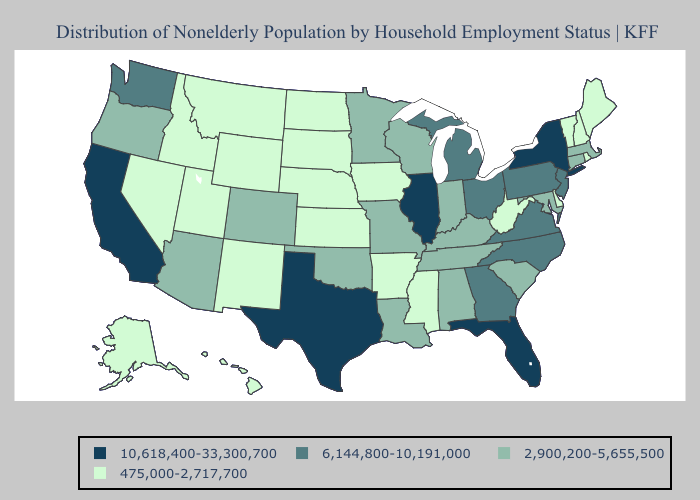Which states hav the highest value in the South?
Short answer required. Florida, Texas. Does South Carolina have the lowest value in the USA?
Write a very short answer. No. What is the highest value in the USA?
Answer briefly. 10,618,400-33,300,700. Does Alaska have the highest value in the USA?
Write a very short answer. No. What is the value of Massachusetts?
Be succinct. 2,900,200-5,655,500. Does Iowa have the lowest value in the MidWest?
Be succinct. Yes. Does the first symbol in the legend represent the smallest category?
Keep it brief. No. What is the value of Washington?
Be succinct. 6,144,800-10,191,000. Which states have the highest value in the USA?
Write a very short answer. California, Florida, Illinois, New York, Texas. Does Kansas have the lowest value in the USA?
Give a very brief answer. Yes. Name the states that have a value in the range 6,144,800-10,191,000?
Concise answer only. Georgia, Michigan, New Jersey, North Carolina, Ohio, Pennsylvania, Virginia, Washington. What is the highest value in the MidWest ?
Be succinct. 10,618,400-33,300,700. Does the map have missing data?
Be succinct. No. How many symbols are there in the legend?
Keep it brief. 4. Name the states that have a value in the range 6,144,800-10,191,000?
Short answer required. Georgia, Michigan, New Jersey, North Carolina, Ohio, Pennsylvania, Virginia, Washington. 